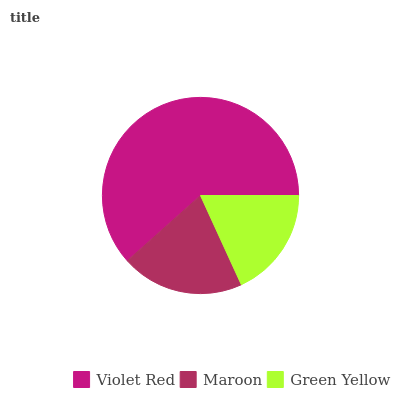Is Green Yellow the minimum?
Answer yes or no. Yes. Is Violet Red the maximum?
Answer yes or no. Yes. Is Maroon the minimum?
Answer yes or no. No. Is Maroon the maximum?
Answer yes or no. No. Is Violet Red greater than Maroon?
Answer yes or no. Yes. Is Maroon less than Violet Red?
Answer yes or no. Yes. Is Maroon greater than Violet Red?
Answer yes or no. No. Is Violet Red less than Maroon?
Answer yes or no. No. Is Maroon the high median?
Answer yes or no. Yes. Is Maroon the low median?
Answer yes or no. Yes. Is Green Yellow the high median?
Answer yes or no. No. Is Green Yellow the low median?
Answer yes or no. No. 